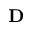<formula> <loc_0><loc_0><loc_500><loc_500>D</formula> 